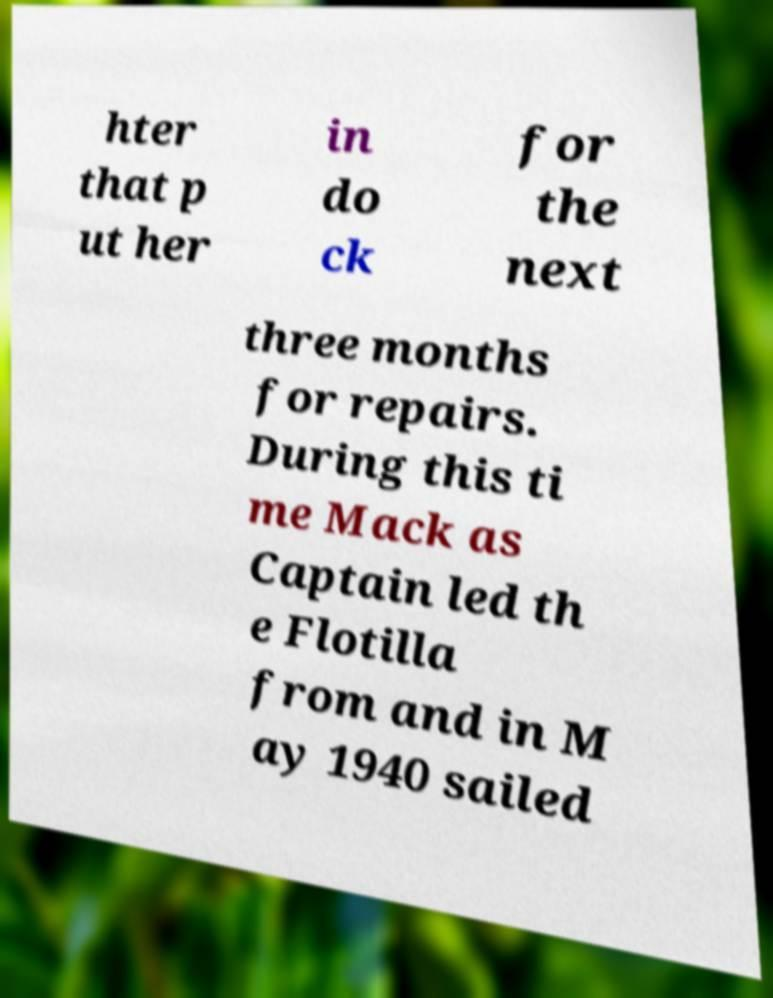There's text embedded in this image that I need extracted. Can you transcribe it verbatim? hter that p ut her in do ck for the next three months for repairs. During this ti me Mack as Captain led th e Flotilla from and in M ay 1940 sailed 